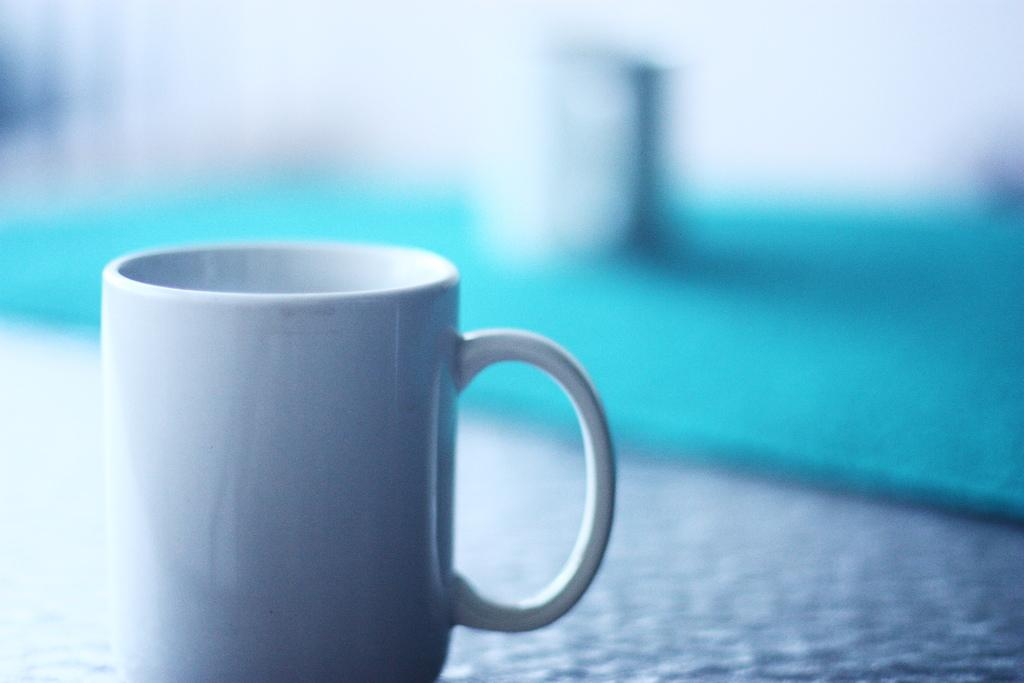What object is visible in the image? There is a cup in the image. What color is the cup? The cup is white in color. Where is the cup located in the image? The cup is on a surface. How would you describe the background of the image? The background of the image is blurry, and the colors are blue and white. How many giraffes can be seen in the image? There are no giraffes present in the image. What type of car is visible in the background of the image? There is no car visible in the image; the background is blurry and consists of blue and white colors. 